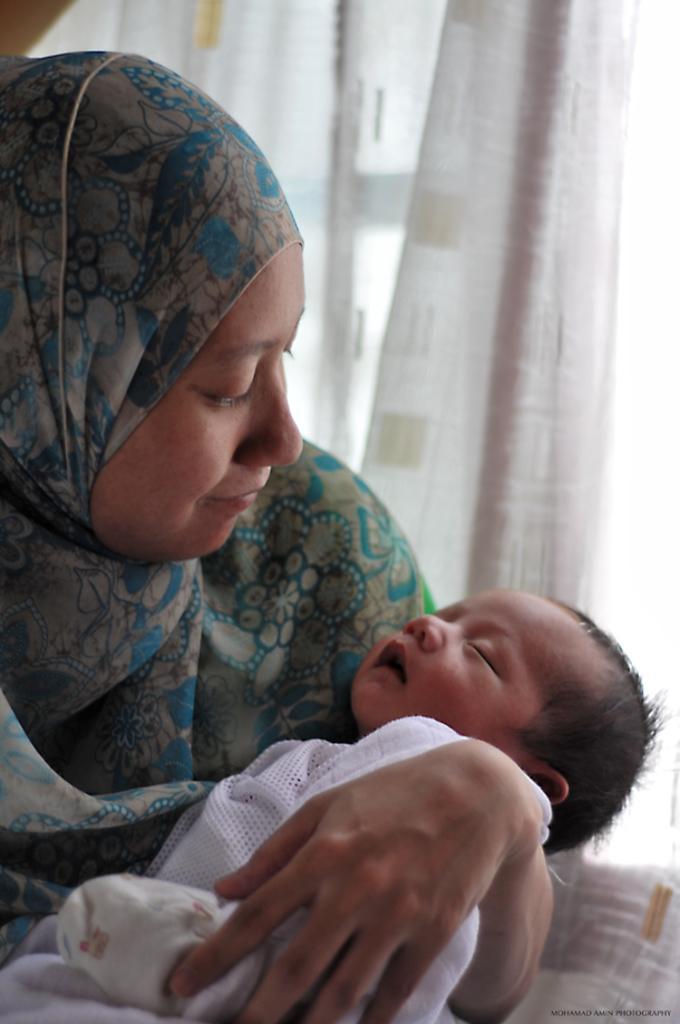Can you describe this image briefly? In the image a woman is holding a baby. Behind her there is a curtain. 